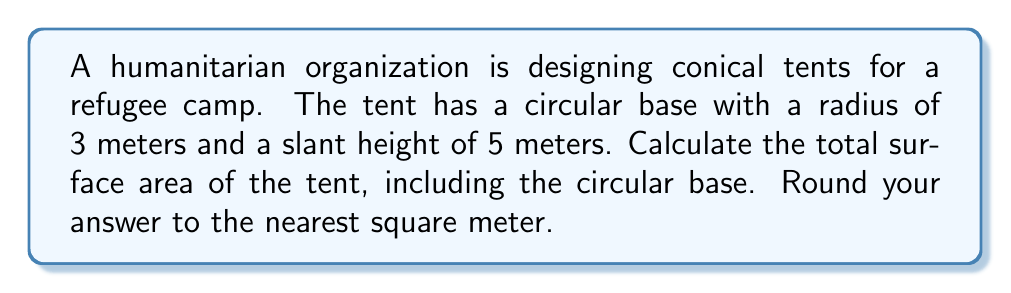Provide a solution to this math problem. To solve this problem, we need to calculate the surface area of a cone, which consists of the lateral surface area (the fabric of the tent) and the circular base area.

Let's break it down step by step:

1. Given information:
   - Radius of the base (r) = 3 meters
   - Slant height (s) = 5 meters

2. Formula for the surface area of a cone:
   $$ A_{total} = A_{lateral} + A_{base} $$
   Where:
   $$ A_{lateral} = \pi rs $$
   $$ A_{base} = \pi r^2 $$

3. Calculate the lateral surface area:
   $$ A_{lateral} = \pi rs = \pi \cdot 3 \cdot 5 = 15\pi \approx 47.12 \text{ m}^2 $$

4. Calculate the base area:
   $$ A_{base} = \pi r^2 = \pi \cdot 3^2 = 9\pi \approx 28.27 \text{ m}^2 $$

5. Sum up the total surface area:
   $$ A_{total} = A_{lateral} + A_{base} = 15\pi + 9\pi = 24\pi \approx 75.40 \text{ m}^2 $$

6. Round to the nearest square meter:
   75.40 m² rounds to 75 m²

[asy]
import geometry;

size(200);
pair O = (0,0);
pair A = (3,0);
pair B = (0,4);

draw(O--A--B--O);
draw(Arc(O,3,0,180));

label("3 m", (1.5,0), S);
label("5 m", (1.5,2), NW);

dot("O", O, SW);
dot("A", A, SE);
dot("B", B, N);
[/asy]
Answer: The total surface area of the conical refugee tent is approximately 75 m². 